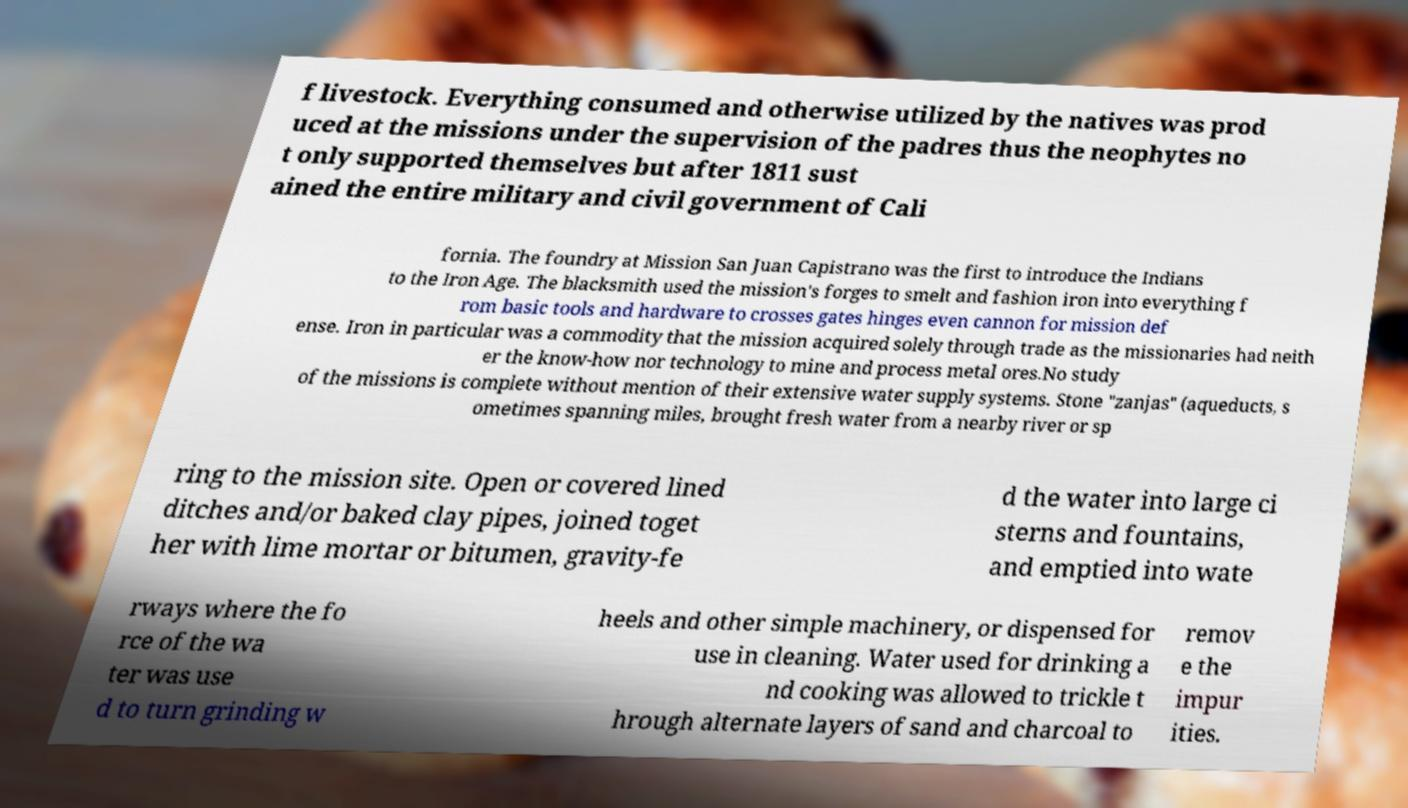Can you accurately transcribe the text from the provided image for me? f livestock. Everything consumed and otherwise utilized by the natives was prod uced at the missions under the supervision of the padres thus the neophytes no t only supported themselves but after 1811 sust ained the entire military and civil government of Cali fornia. The foundry at Mission San Juan Capistrano was the first to introduce the Indians to the Iron Age. The blacksmith used the mission's forges to smelt and fashion iron into everything f rom basic tools and hardware to crosses gates hinges even cannon for mission def ense. Iron in particular was a commodity that the mission acquired solely through trade as the missionaries had neith er the know-how nor technology to mine and process metal ores.No study of the missions is complete without mention of their extensive water supply systems. Stone "zanjas" (aqueducts, s ometimes spanning miles, brought fresh water from a nearby river or sp ring to the mission site. Open or covered lined ditches and/or baked clay pipes, joined toget her with lime mortar or bitumen, gravity-fe d the water into large ci sterns and fountains, and emptied into wate rways where the fo rce of the wa ter was use d to turn grinding w heels and other simple machinery, or dispensed for use in cleaning. Water used for drinking a nd cooking was allowed to trickle t hrough alternate layers of sand and charcoal to remov e the impur ities. 